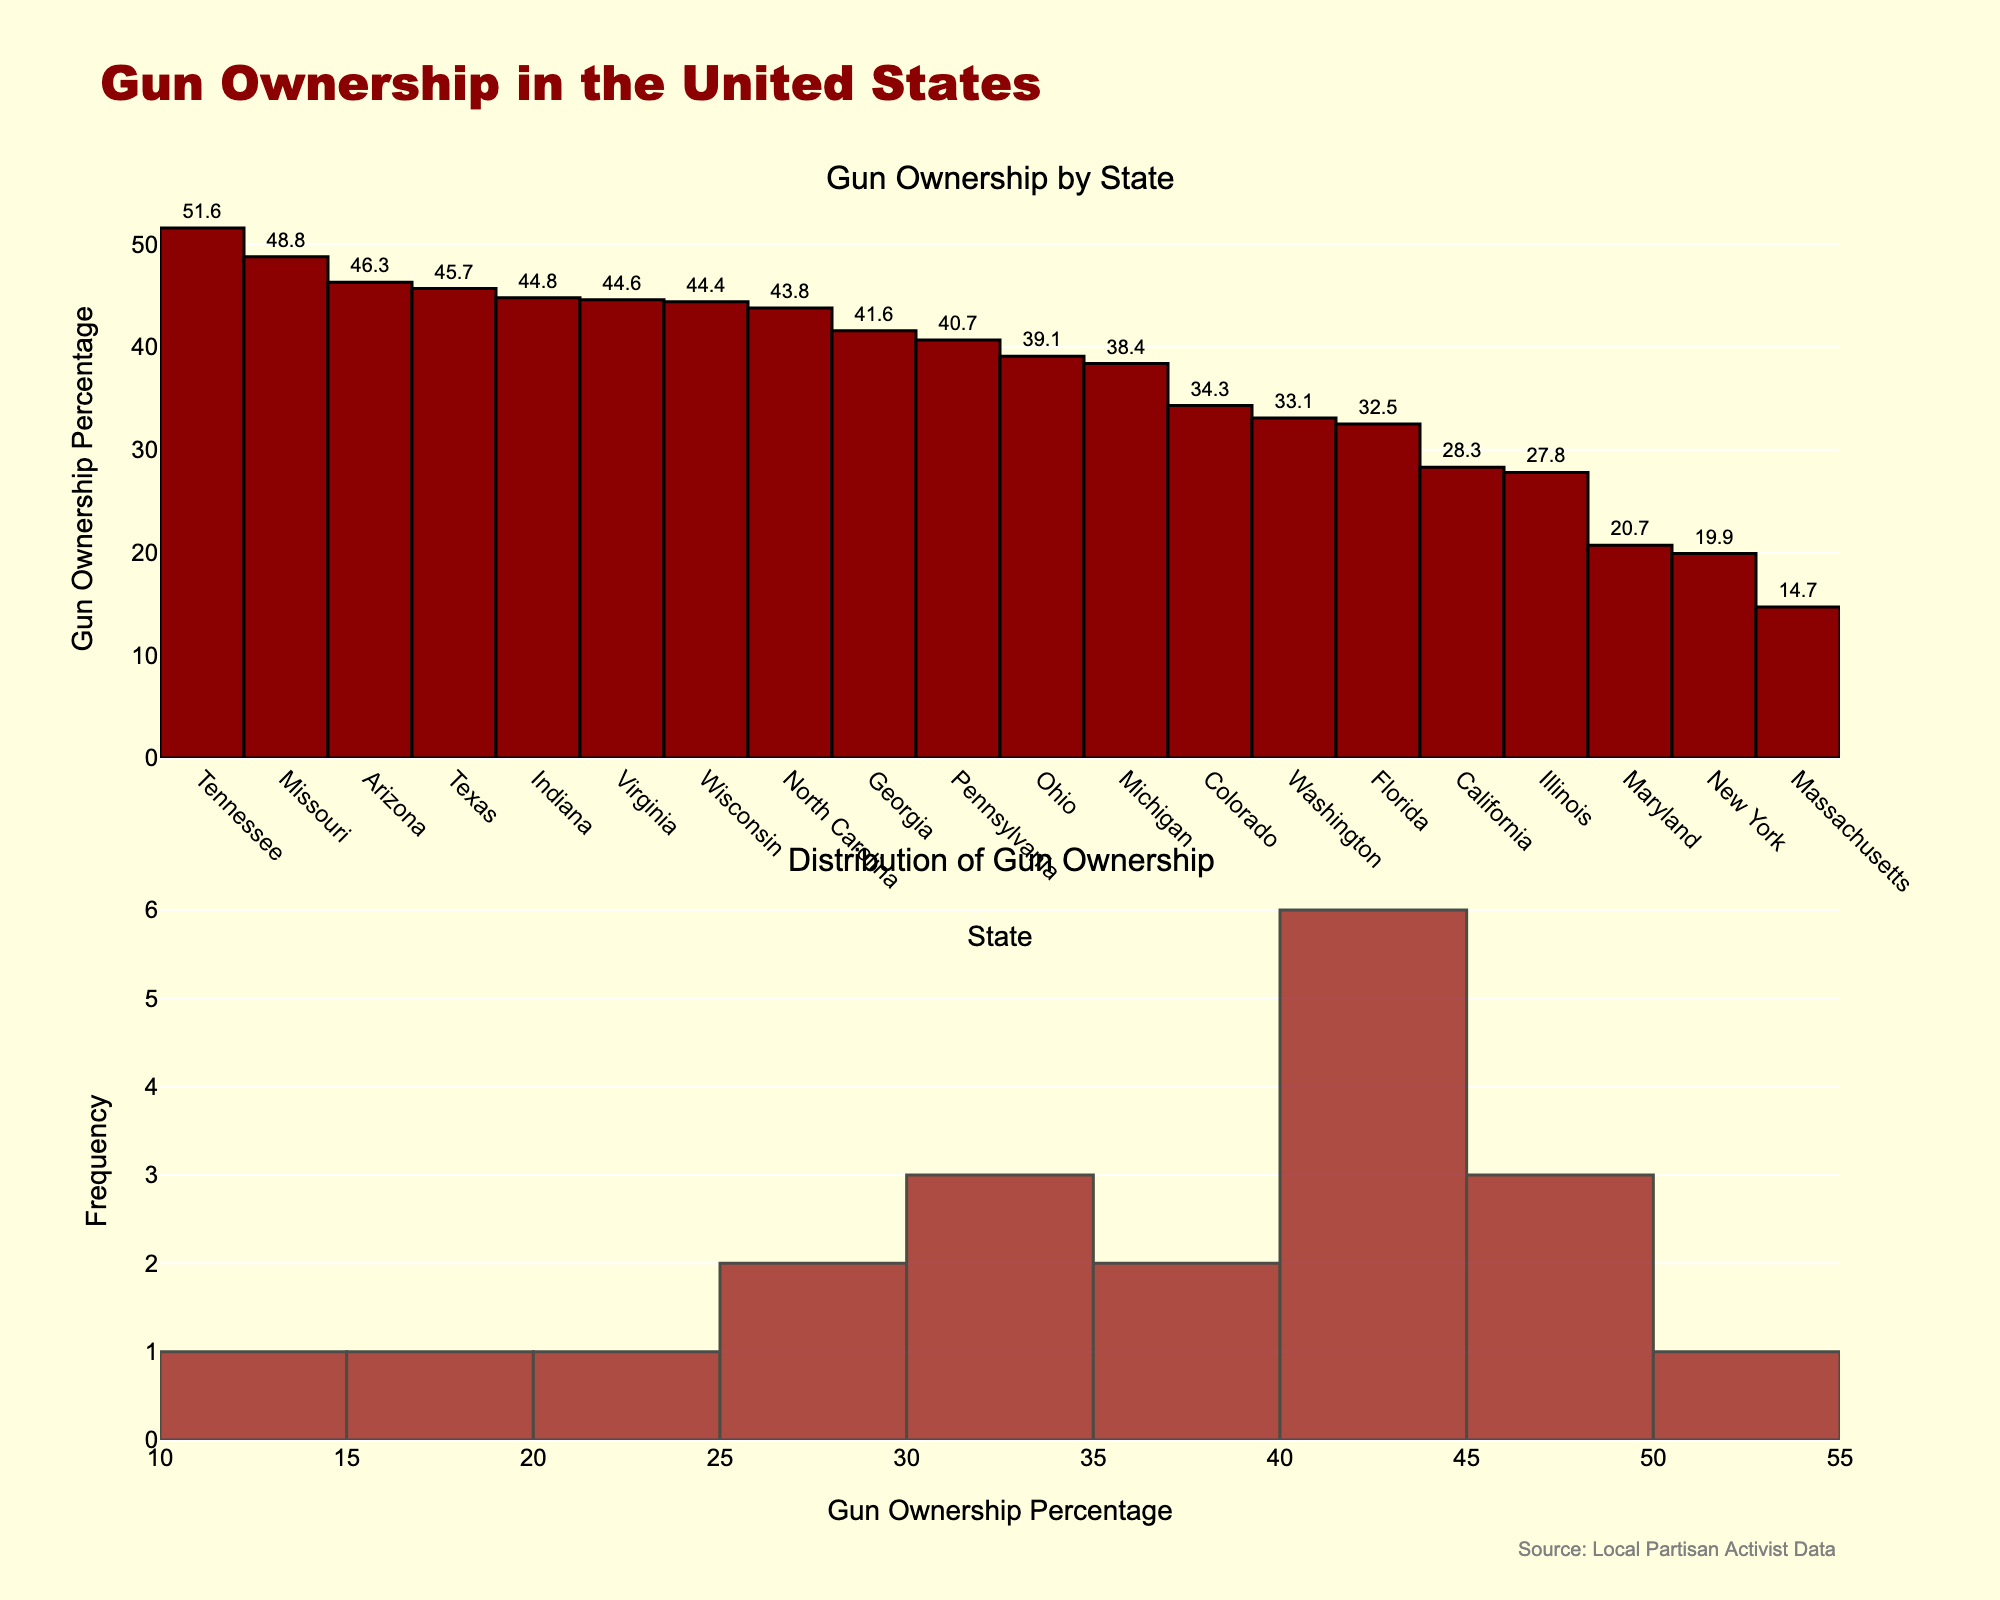What's the title of the figure? The title is often prominently displayed at the top of the plot. Here, it's labeled as "Gun Ownership in the United States." This can be seen from the largest text on the plot set in a distinctive font.
Answer: Gun Ownership in the United States Which state has the highest gun ownership percentage? To determine this, look at the bar chart in the first subplot. The tallest bar represents the state with the highest gun ownership percentage, which is labeled as Tennessee.
Answer: Tennessee How many states have a gun ownership percentage higher than 40%? By examining the bar chart, count the number of states where the bar extends beyond the 40% mark on the y-axis. These states are Tennessee, Arizona, Missouri, Texas, Virginia, Indiana, Wisconsin, Georgia, North Carolina, and Pennsylvania, making a total of ten states.
Answer: 10 What is the median gun ownership percentage? The median is the middle value when sorted in order. From the sorted axis in the bar chart, the middle value (10th or 11th) between Ohio and Michigan is about halfway, giving us a median close to the average of their values, approximately 39%.
Answer: Around 39% Which state has the second-lowest gun ownership percentage? The bar chart shows the lowest gun ownership percentage belongs to Massachusetts. The second-lowest bar beside it represents New York.
Answer: New York How does the gun ownership percentage of California compare to Pennsylvania? The bar for California is shorter, indicating a lower percentage compared to Pennsylvania. Specifically, California has 28.3%, while Pennsylvania has 40.7% gun ownership.
Answer: Lower What is the frequency distribution of gun ownership percentages? Look at the histogram in the second subplot. The x-axis shows the percentage ranges, and the y-axis shows the frequency of states within each range. The histogram distribution indicates that most states have gun ownership percentages clustered around 40-50%.
Answer: Clustered around 40-50% What is the range of gun ownership percentages shown in the figure? By observing the smallest and largest values in both subplots, the range extends from Massachusetts’ 14.7% to Tennessee’s 51.6%.
Answer: 14.7% to 51.6% How many states have a gun ownership percentage below 20%? By checking the bar chart, only the bars for Massachusetts and New York fall below the 20% mark.
Answer: 2 What does the annotation at the bottom of the figure refer to? The annotation states "Source: Local Partisan Activist Data," indicating the data source used for the plot. This information is typically included for transparency and credibility.
Answer: Source: Local Partisan Activist Data 